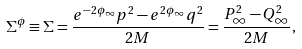Convert formula to latex. <formula><loc_0><loc_0><loc_500><loc_500>\Sigma ^ { \phi } \equiv \Sigma = \frac { e ^ { - 2 \phi _ { \infty } } p ^ { 2 } - e ^ { 2 \phi _ { \infty } } q ^ { 2 } } { 2 M } = \frac { P _ { \infty } ^ { 2 } - Q _ { \infty } ^ { 2 } } { 2 M } ,</formula> 